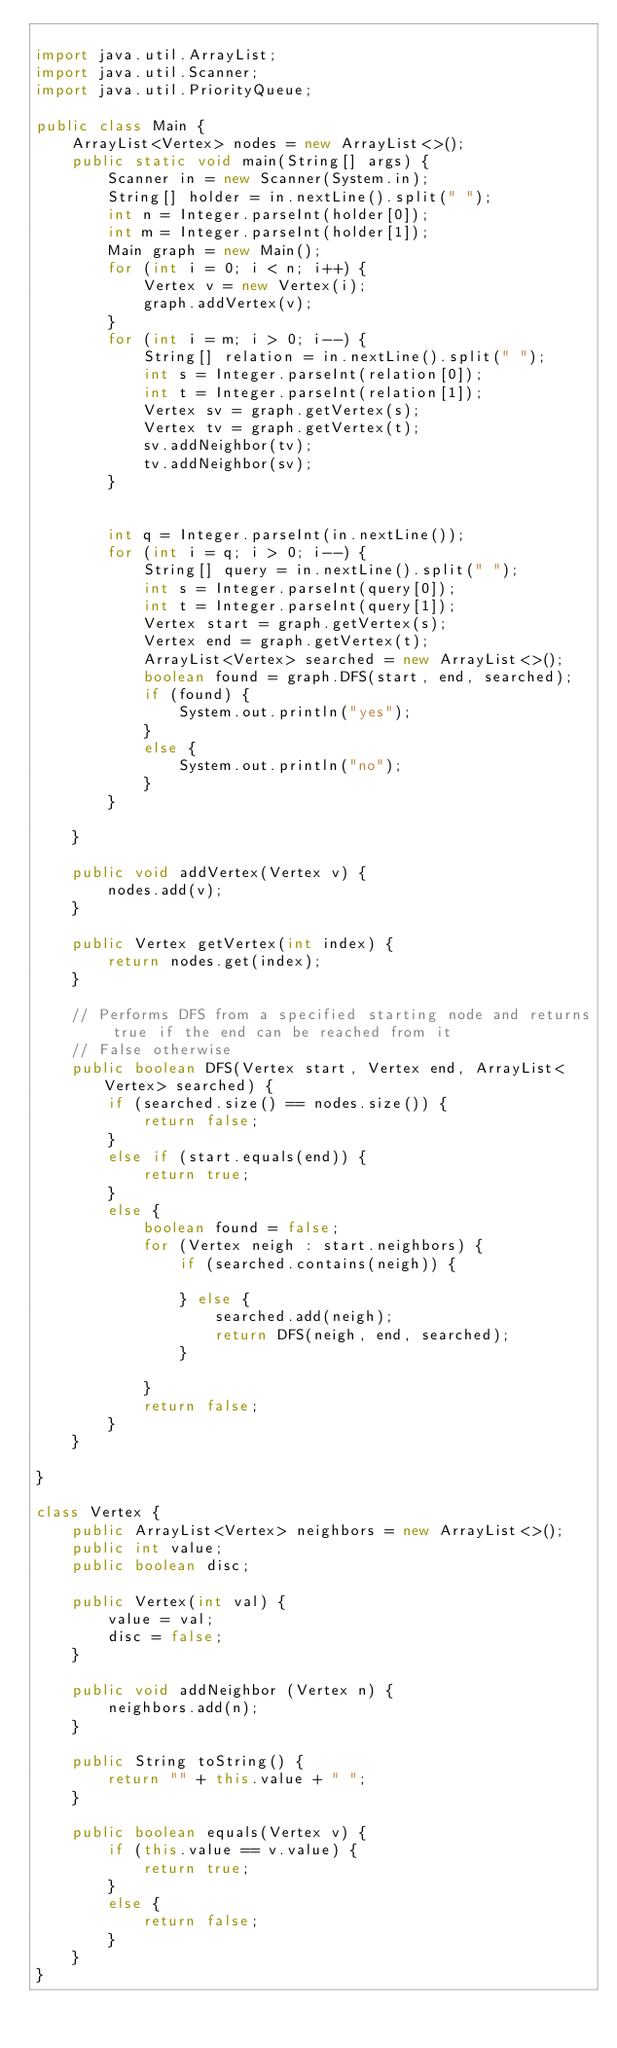Convert code to text. <code><loc_0><loc_0><loc_500><loc_500><_Java_>
import java.util.ArrayList;
import java.util.Scanner;
import java.util.PriorityQueue;

public class Main {
	ArrayList<Vertex> nodes = new ArrayList<>();
	public static void main(String[] args) {
		Scanner in = new Scanner(System.in);
		String[] holder = in.nextLine().split(" ");
		int n = Integer.parseInt(holder[0]);
		int m = Integer.parseInt(holder[1]);
		Main graph = new Main();
		for (int i = 0; i < n; i++) {
			Vertex v = new Vertex(i);
			graph.addVertex(v);
		}
		for (int i = m; i > 0; i--) {
			String[] relation = in.nextLine().split(" ");
			int s = Integer.parseInt(relation[0]);
			int t = Integer.parseInt(relation[1]);
			Vertex sv = graph.getVertex(s);
			Vertex tv = graph.getVertex(t);
			sv.addNeighbor(tv);
			tv.addNeighbor(sv);
		}
		
		
		int q = Integer.parseInt(in.nextLine());
		for (int i = q; i > 0; i--) {
			String[] query = in.nextLine().split(" ");
			int s = Integer.parseInt(query[0]);
			int t = Integer.parseInt(query[1]);
			Vertex start = graph.getVertex(s);
			Vertex end = graph.getVertex(t);
			ArrayList<Vertex> searched = new ArrayList<>();
			boolean found = graph.DFS(start, end, searched);
			if (found) {
				System.out.println("yes");
			}
			else {
				System.out.println("no");
			}
		}
		
	}	
		
	public void addVertex(Vertex v) {
		nodes.add(v);
	}
	
	public Vertex getVertex(int index) {
		return nodes.get(index);
	}
	
	// Performs DFS from a specified starting node and returns true if the end can be reached from it
	// False otherwise
	public boolean DFS(Vertex start, Vertex end, ArrayList<Vertex> searched) {	
		if (searched.size() == nodes.size()) {
			return false;
		}
		else if (start.equals(end)) {
			return true;
		}
		else {
			boolean found = false;
			for (Vertex neigh : start.neighbors) {
				if (searched.contains(neigh)) {
					
				} else {
					searched.add(neigh);
					return DFS(neigh, end, searched);
				}
				
			}
			return false;
		}
	}
	
}

class Vertex {
	public ArrayList<Vertex> neighbors = new ArrayList<>();
	public int value;
	public boolean disc;
	
	public Vertex(int val) {
		value = val;
		disc = false;
	}
	
	public void addNeighbor (Vertex n) {
		neighbors.add(n);
	}
	
	public String toString() {
		return "" + this.value + " ";
	}
	
	public boolean equals(Vertex v) {
		if (this.value == v.value) {
			return true;
		}
		else {
			return false;
		}
	}
}


</code> 